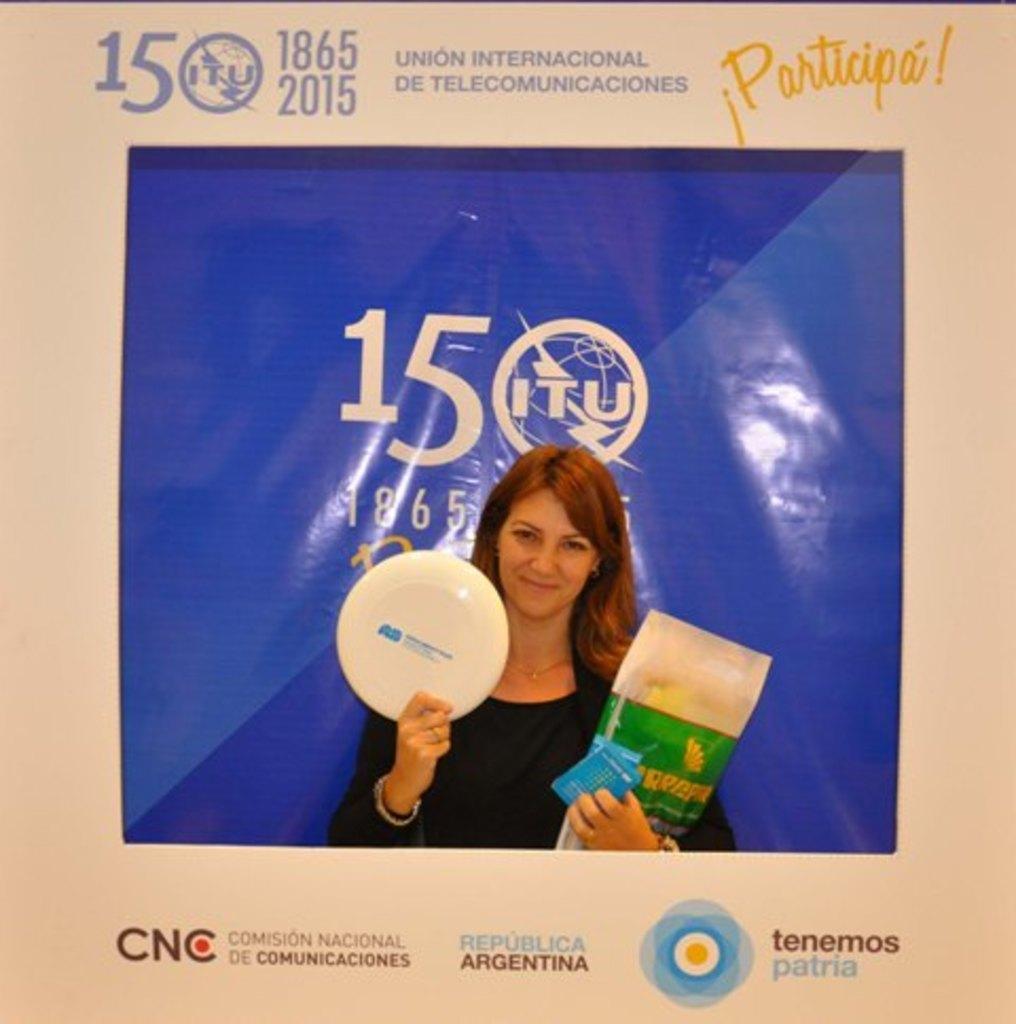How would you summarize this image in a sentence or two? In this image I can see a poster. On the poster there is a picture of a person holding some objects. Also there are words, numbers and logos on the poster. 